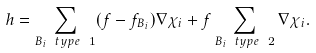Convert formula to latex. <formula><loc_0><loc_0><loc_500><loc_500>h = \sum _ { B _ { i } \ t y p e \ 1 } ( f - f _ { B _ { i } } ) \nabla \chi _ { i } + f \sum _ { B _ { i } \ t y p e \ 2 } \nabla \chi _ { i } .</formula> 